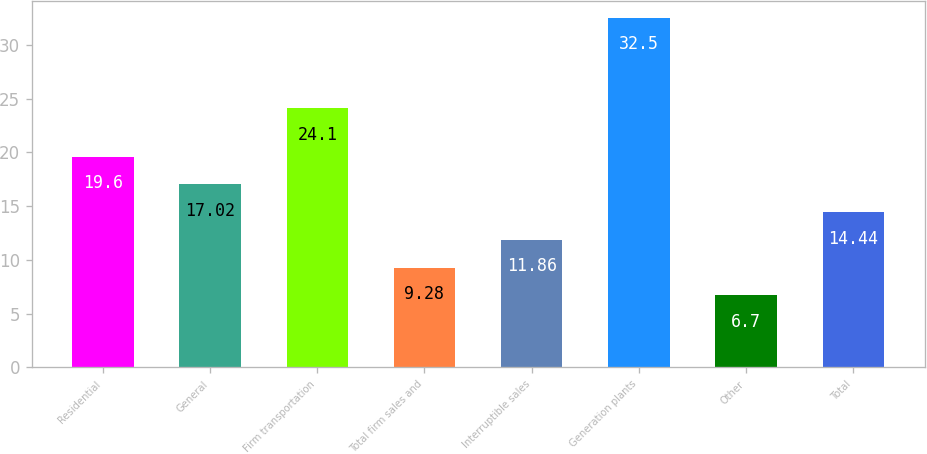Convert chart to OTSL. <chart><loc_0><loc_0><loc_500><loc_500><bar_chart><fcel>Residential<fcel>General<fcel>Firm transportation<fcel>Total firm sales and<fcel>Interruptible sales<fcel>Generation plants<fcel>Other<fcel>Total<nl><fcel>19.6<fcel>17.02<fcel>24.1<fcel>9.28<fcel>11.86<fcel>32.5<fcel>6.7<fcel>14.44<nl></chart> 